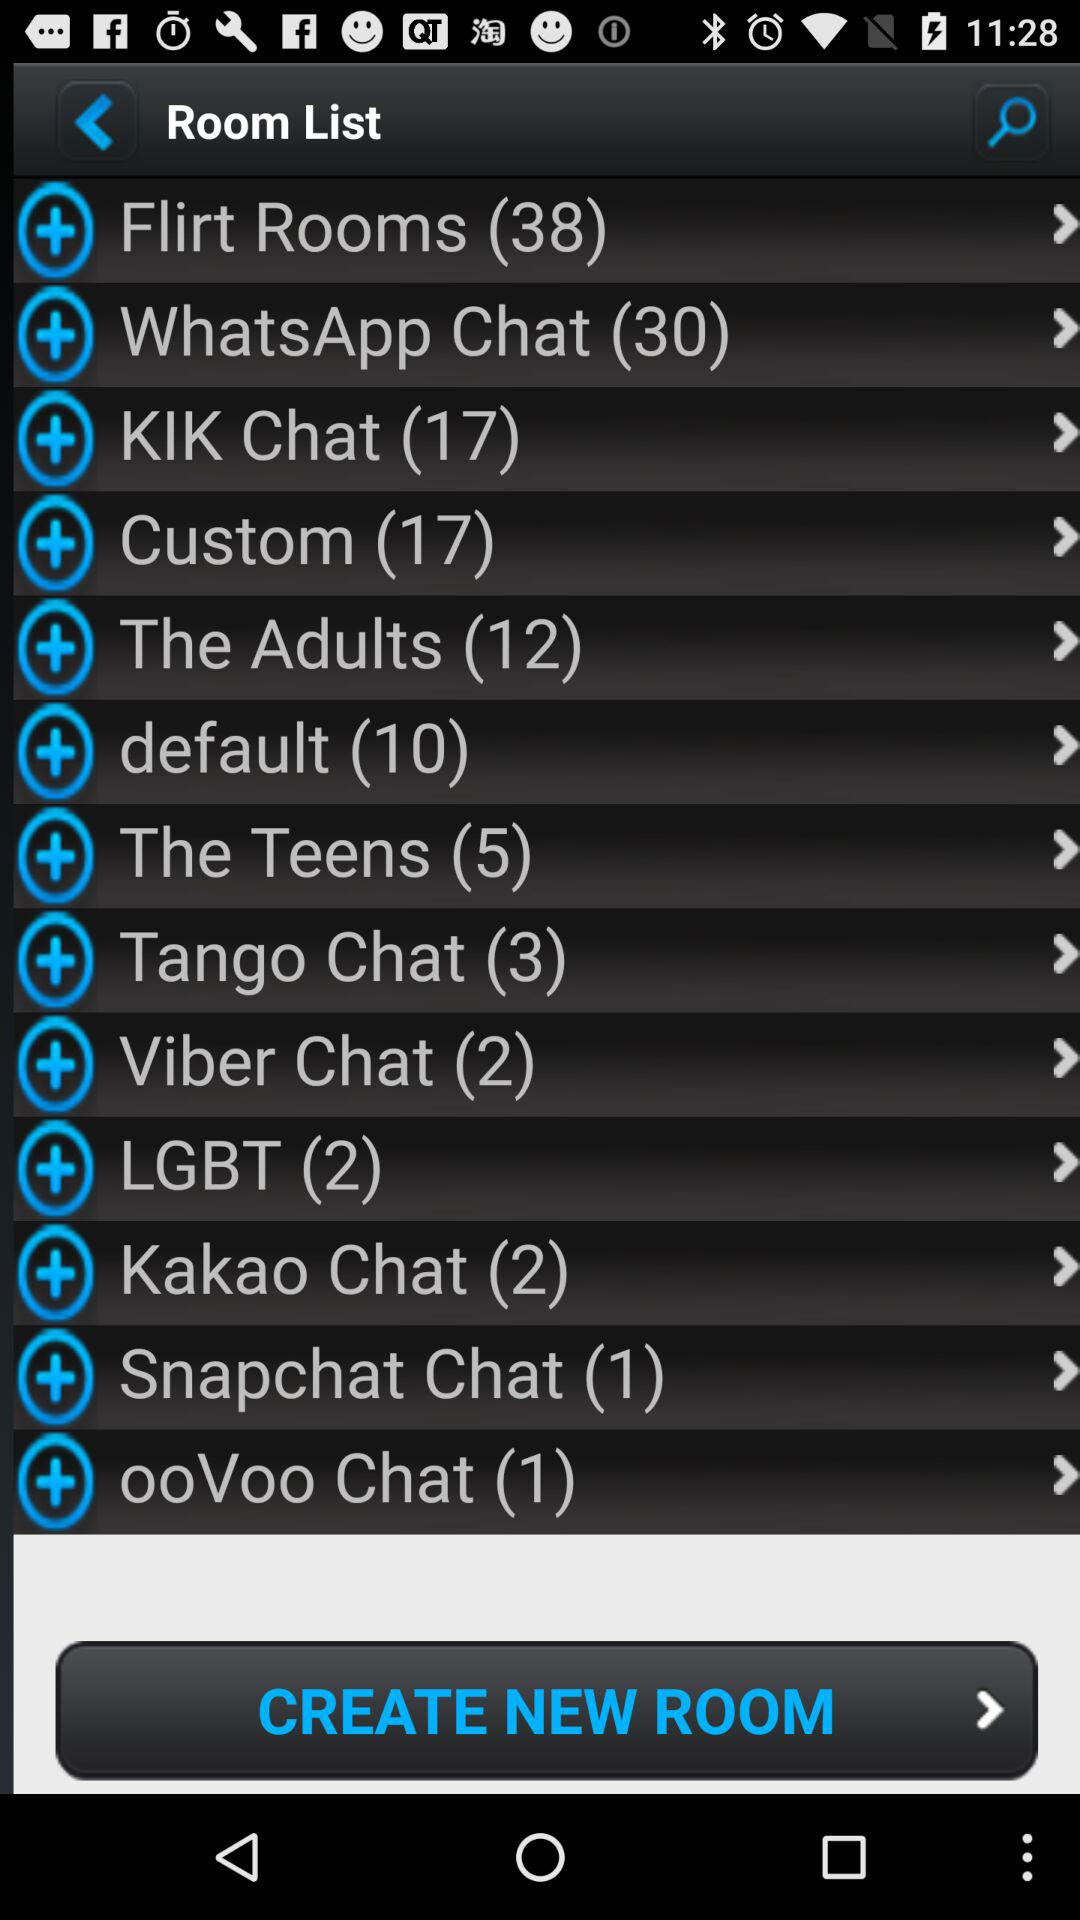What is the room list for Snapchat chat? The room list for Snapchat chat is 1. 